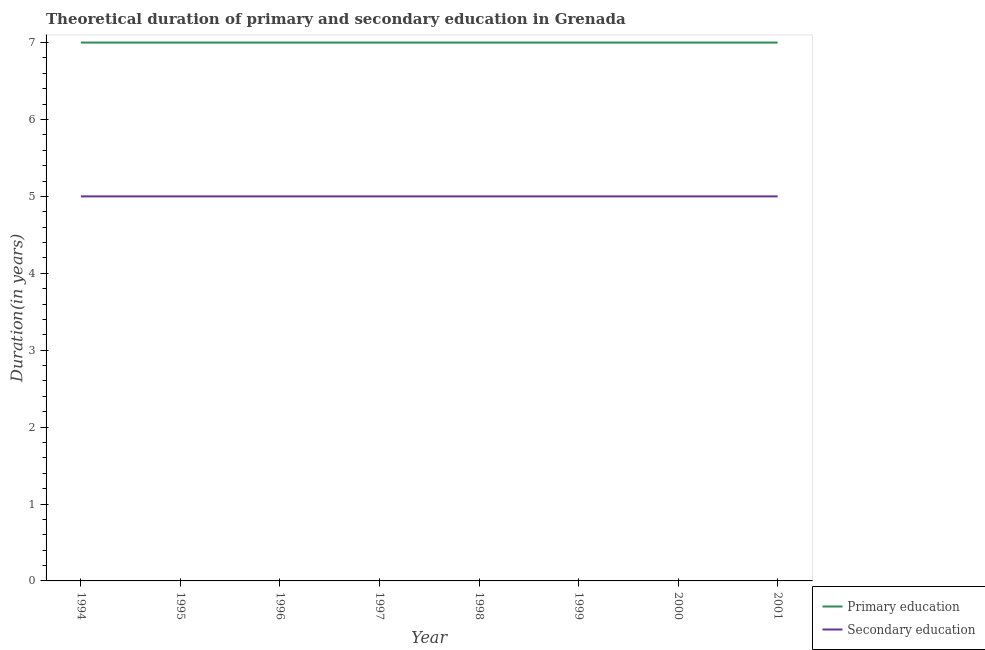What is the duration of secondary education in 1999?
Give a very brief answer. 5. Across all years, what is the maximum duration of secondary education?
Offer a terse response. 5. Across all years, what is the minimum duration of secondary education?
Your answer should be very brief. 5. In which year was the duration of secondary education maximum?
Offer a terse response. 1994. In which year was the duration of primary education minimum?
Offer a very short reply. 1994. What is the total duration of secondary education in the graph?
Your response must be concise. 40. What is the difference between the duration of primary education in 1994 and that in 1995?
Provide a succinct answer. 0. What is the difference between the duration of primary education in 1994 and the duration of secondary education in 1995?
Offer a very short reply. 2. In the year 1995, what is the difference between the duration of primary education and duration of secondary education?
Ensure brevity in your answer.  2. Is the duration of secondary education in 2000 less than that in 2001?
Offer a terse response. No. What is the difference between the highest and the second highest duration of secondary education?
Offer a very short reply. 0. What is the difference between the highest and the lowest duration of primary education?
Give a very brief answer. 0. In how many years, is the duration of primary education greater than the average duration of primary education taken over all years?
Your answer should be compact. 0. Is the duration of primary education strictly greater than the duration of secondary education over the years?
Make the answer very short. Yes. Is the duration of primary education strictly less than the duration of secondary education over the years?
Make the answer very short. No. How many lines are there?
Ensure brevity in your answer.  2. What is the difference between two consecutive major ticks on the Y-axis?
Keep it short and to the point. 1. Does the graph contain grids?
Offer a terse response. No. What is the title of the graph?
Offer a very short reply. Theoretical duration of primary and secondary education in Grenada. Does "Time to export" appear as one of the legend labels in the graph?
Your answer should be very brief. No. What is the label or title of the X-axis?
Offer a terse response. Year. What is the label or title of the Y-axis?
Keep it short and to the point. Duration(in years). What is the Duration(in years) of Secondary education in 1994?
Make the answer very short. 5. What is the Duration(in years) of Primary education in 1995?
Offer a terse response. 7. What is the Duration(in years) in Secondary education in 1995?
Give a very brief answer. 5. What is the Duration(in years) of Primary education in 1997?
Provide a succinct answer. 7. What is the Duration(in years) of Secondary education in 1998?
Keep it short and to the point. 5. What is the Duration(in years) of Primary education in 2000?
Your answer should be very brief. 7. What is the Duration(in years) in Secondary education in 2001?
Provide a succinct answer. 5. Across all years, what is the maximum Duration(in years) in Primary education?
Your answer should be very brief. 7. Across all years, what is the maximum Duration(in years) of Secondary education?
Give a very brief answer. 5. What is the total Duration(in years) in Secondary education in the graph?
Your answer should be very brief. 40. What is the difference between the Duration(in years) of Primary education in 1994 and that in 1996?
Provide a succinct answer. 0. What is the difference between the Duration(in years) in Secondary education in 1994 and that in 1996?
Your response must be concise. 0. What is the difference between the Duration(in years) in Primary education in 1994 and that in 1997?
Make the answer very short. 0. What is the difference between the Duration(in years) in Primary education in 1994 and that in 2000?
Keep it short and to the point. 0. What is the difference between the Duration(in years) of Secondary education in 1994 and that in 2001?
Provide a succinct answer. 0. What is the difference between the Duration(in years) of Primary education in 1995 and that in 1997?
Provide a succinct answer. 0. What is the difference between the Duration(in years) in Secondary education in 1995 and that in 1997?
Offer a terse response. 0. What is the difference between the Duration(in years) in Secondary education in 1995 and that in 1999?
Provide a short and direct response. 0. What is the difference between the Duration(in years) in Primary education in 1995 and that in 2000?
Offer a very short reply. 0. What is the difference between the Duration(in years) of Primary education in 1996 and that in 1997?
Offer a very short reply. 0. What is the difference between the Duration(in years) of Primary education in 1996 and that in 1998?
Your answer should be very brief. 0. What is the difference between the Duration(in years) in Primary education in 1996 and that in 2001?
Your answer should be compact. 0. What is the difference between the Duration(in years) of Secondary education in 1997 and that in 1999?
Provide a succinct answer. 0. What is the difference between the Duration(in years) in Secondary education in 1997 and that in 2000?
Ensure brevity in your answer.  0. What is the difference between the Duration(in years) of Primary education in 1997 and that in 2001?
Your answer should be compact. 0. What is the difference between the Duration(in years) in Primary education in 1998 and that in 1999?
Your response must be concise. 0. What is the difference between the Duration(in years) of Primary education in 1998 and that in 2000?
Offer a very short reply. 0. What is the difference between the Duration(in years) of Secondary education in 1998 and that in 2000?
Offer a terse response. 0. What is the difference between the Duration(in years) of Primary education in 1999 and that in 2000?
Ensure brevity in your answer.  0. What is the difference between the Duration(in years) in Secondary education in 1999 and that in 2000?
Ensure brevity in your answer.  0. What is the difference between the Duration(in years) in Primary education in 1999 and that in 2001?
Your answer should be very brief. 0. What is the difference between the Duration(in years) in Secondary education in 1999 and that in 2001?
Give a very brief answer. 0. What is the difference between the Duration(in years) in Primary education in 2000 and that in 2001?
Ensure brevity in your answer.  0. What is the difference between the Duration(in years) in Secondary education in 2000 and that in 2001?
Provide a succinct answer. 0. What is the difference between the Duration(in years) of Primary education in 1994 and the Duration(in years) of Secondary education in 1995?
Offer a very short reply. 2. What is the difference between the Duration(in years) of Primary education in 1994 and the Duration(in years) of Secondary education in 1997?
Your answer should be very brief. 2. What is the difference between the Duration(in years) in Primary education in 1994 and the Duration(in years) in Secondary education in 2000?
Your response must be concise. 2. What is the difference between the Duration(in years) in Primary education in 1994 and the Duration(in years) in Secondary education in 2001?
Keep it short and to the point. 2. What is the difference between the Duration(in years) of Primary education in 1995 and the Duration(in years) of Secondary education in 1996?
Provide a short and direct response. 2. What is the difference between the Duration(in years) of Primary education in 1995 and the Duration(in years) of Secondary education in 1997?
Offer a very short reply. 2. What is the difference between the Duration(in years) of Primary education in 1996 and the Duration(in years) of Secondary education in 1997?
Give a very brief answer. 2. What is the difference between the Duration(in years) of Primary education in 1996 and the Duration(in years) of Secondary education in 1998?
Offer a very short reply. 2. What is the difference between the Duration(in years) of Primary education in 1996 and the Duration(in years) of Secondary education in 1999?
Your response must be concise. 2. What is the difference between the Duration(in years) of Primary education in 1997 and the Duration(in years) of Secondary education in 1998?
Provide a short and direct response. 2. What is the difference between the Duration(in years) in Primary education in 1997 and the Duration(in years) in Secondary education in 1999?
Your answer should be compact. 2. What is the difference between the Duration(in years) in Primary education in 1997 and the Duration(in years) in Secondary education in 2001?
Your answer should be compact. 2. What is the difference between the Duration(in years) in Primary education in 1998 and the Duration(in years) in Secondary education in 1999?
Provide a short and direct response. 2. What is the average Duration(in years) in Secondary education per year?
Offer a very short reply. 5. In the year 1994, what is the difference between the Duration(in years) of Primary education and Duration(in years) of Secondary education?
Offer a terse response. 2. In the year 1995, what is the difference between the Duration(in years) of Primary education and Duration(in years) of Secondary education?
Give a very brief answer. 2. In the year 1996, what is the difference between the Duration(in years) in Primary education and Duration(in years) in Secondary education?
Your answer should be compact. 2. In the year 1997, what is the difference between the Duration(in years) in Primary education and Duration(in years) in Secondary education?
Your answer should be very brief. 2. In the year 1998, what is the difference between the Duration(in years) in Primary education and Duration(in years) in Secondary education?
Make the answer very short. 2. In the year 1999, what is the difference between the Duration(in years) in Primary education and Duration(in years) in Secondary education?
Your answer should be compact. 2. In the year 2001, what is the difference between the Duration(in years) of Primary education and Duration(in years) of Secondary education?
Your response must be concise. 2. What is the ratio of the Duration(in years) in Secondary education in 1994 to that in 1996?
Provide a succinct answer. 1. What is the ratio of the Duration(in years) in Secondary education in 1994 to that in 1997?
Offer a very short reply. 1. What is the ratio of the Duration(in years) of Secondary education in 1994 to that in 1998?
Offer a terse response. 1. What is the ratio of the Duration(in years) in Primary education in 1994 to that in 2000?
Offer a very short reply. 1. What is the ratio of the Duration(in years) of Primary education in 1994 to that in 2001?
Offer a very short reply. 1. What is the ratio of the Duration(in years) in Secondary education in 1994 to that in 2001?
Make the answer very short. 1. What is the ratio of the Duration(in years) of Primary education in 1995 to that in 1996?
Offer a very short reply. 1. What is the ratio of the Duration(in years) in Primary education in 1995 to that in 1997?
Your answer should be compact. 1. What is the ratio of the Duration(in years) of Secondary education in 1995 to that in 1997?
Your answer should be very brief. 1. What is the ratio of the Duration(in years) of Primary education in 1995 to that in 1998?
Provide a succinct answer. 1. What is the ratio of the Duration(in years) in Primary education in 1995 to that in 1999?
Your answer should be very brief. 1. What is the ratio of the Duration(in years) of Primary education in 1995 to that in 2000?
Make the answer very short. 1. What is the ratio of the Duration(in years) of Primary education in 1995 to that in 2001?
Offer a very short reply. 1. What is the ratio of the Duration(in years) in Secondary education in 1996 to that in 1997?
Provide a succinct answer. 1. What is the ratio of the Duration(in years) of Primary education in 1996 to that in 1998?
Provide a short and direct response. 1. What is the ratio of the Duration(in years) in Secondary education in 1996 to that in 1998?
Offer a very short reply. 1. What is the ratio of the Duration(in years) in Primary education in 1996 to that in 1999?
Offer a very short reply. 1. What is the ratio of the Duration(in years) of Primary education in 1996 to that in 2001?
Your response must be concise. 1. What is the ratio of the Duration(in years) in Secondary education in 1997 to that in 1998?
Give a very brief answer. 1. What is the ratio of the Duration(in years) in Primary education in 1997 to that in 1999?
Make the answer very short. 1. What is the ratio of the Duration(in years) of Primary education in 1997 to that in 2001?
Offer a terse response. 1. What is the ratio of the Duration(in years) of Secondary education in 1998 to that in 1999?
Offer a very short reply. 1. What is the ratio of the Duration(in years) in Secondary education in 1998 to that in 2001?
Provide a succinct answer. 1. What is the ratio of the Duration(in years) in Primary education in 1999 to that in 2000?
Your answer should be very brief. 1. What is the difference between the highest and the lowest Duration(in years) in Primary education?
Ensure brevity in your answer.  0. What is the difference between the highest and the lowest Duration(in years) of Secondary education?
Your response must be concise. 0. 